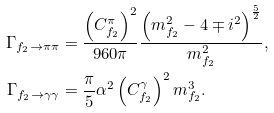Convert formula to latex. <formula><loc_0><loc_0><loc_500><loc_500>\Gamma _ { f _ { 2 } \to \pi \pi } & = \frac { \left ( C _ { f _ { 2 } } ^ { \pi } \right ) ^ { 2 } } { 9 6 0 \pi } \frac { \left ( m _ { f _ { 2 } } ^ { 2 } - 4 \mp i ^ { 2 } \right ) ^ { \frac { 5 } { 2 } } } { m _ { f _ { 2 } } ^ { 2 } } , \\ \Gamma _ { f _ { 2 } \to \gamma \gamma } & = \frac { \pi } { 5 } \alpha ^ { 2 } \left ( C _ { f _ { 2 } } ^ { \gamma } \right ) ^ { 2 } m _ { f _ { 2 } } ^ { 3 } .</formula> 